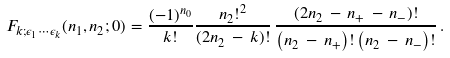Convert formula to latex. <formula><loc_0><loc_0><loc_500><loc_500>F _ { k ; \epsilon _ { 1 } \cdots \epsilon _ { k } } ( n _ { 1 } , n _ { 2 } ; 0 ) = \frac { ( - 1 ) ^ { n _ { 0 } } } { k ! } \frac { n _ { 2 } ! ^ { 2 } } { ( 2 n _ { 2 } \, - \, k ) ! } \, \frac { ( 2 n _ { 2 } \, - \, n _ { + } \, - \, n _ { - } ) ! } { \left ( n _ { 2 } \, - \, n _ { + } \right ) ! \left ( n _ { 2 } \, - \, n _ { - } \right ) ! } \, .</formula> 